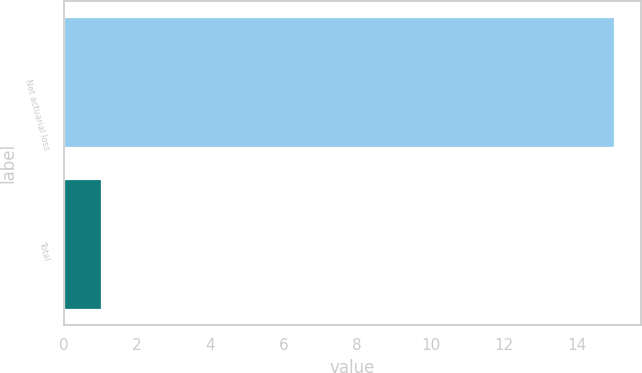<chart> <loc_0><loc_0><loc_500><loc_500><bar_chart><fcel>Net actuarial loss<fcel>Total<nl><fcel>15<fcel>1<nl></chart> 